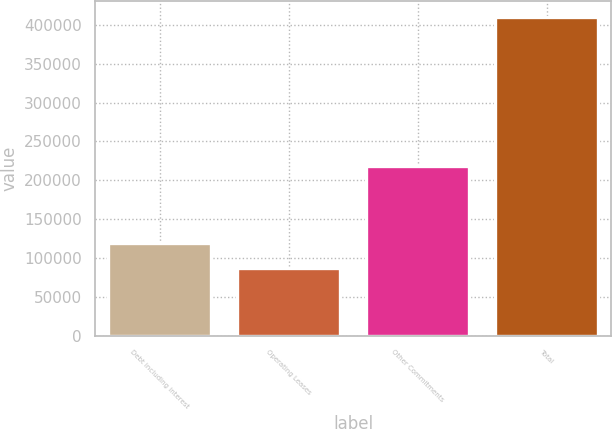Convert chart. <chart><loc_0><loc_0><loc_500><loc_500><bar_chart><fcel>Debt including interest<fcel>Operating Leases<fcel>Other Commitments<fcel>Total<nl><fcel>119148<fcel>86839<fcel>218284<fcel>409930<nl></chart> 